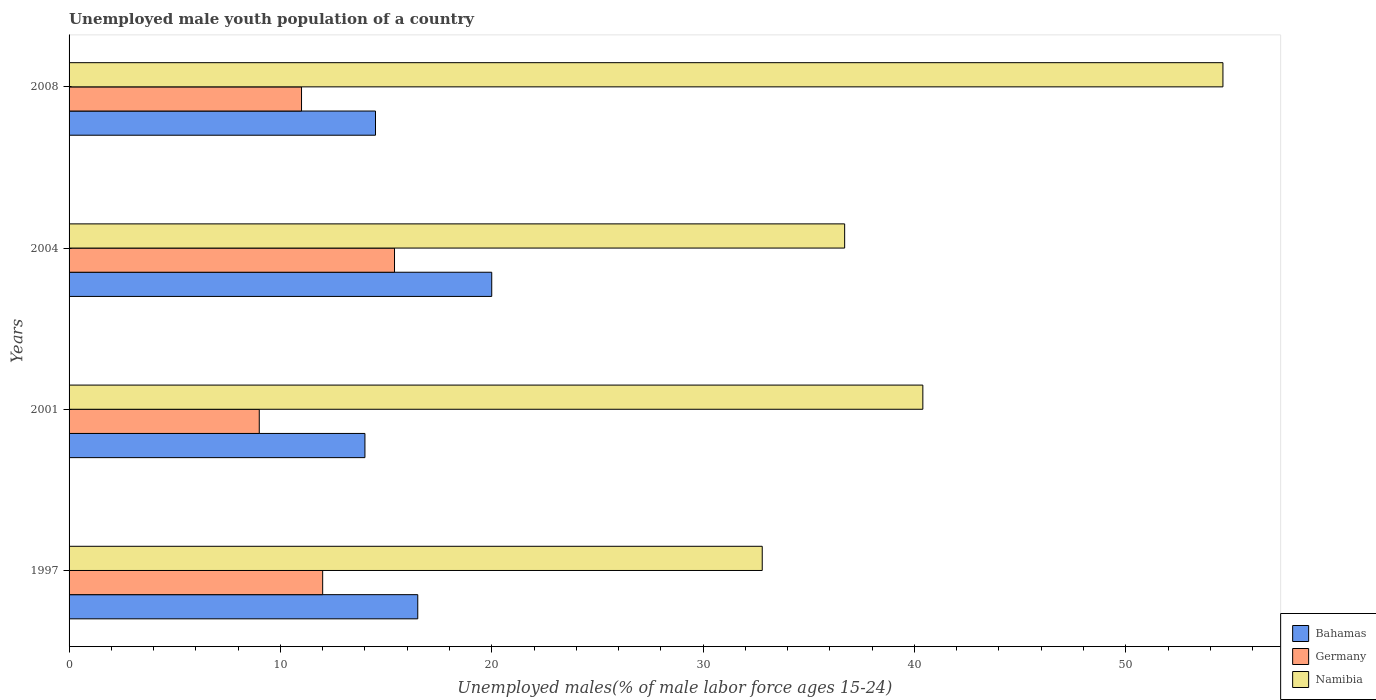How many groups of bars are there?
Provide a succinct answer. 4. Are the number of bars per tick equal to the number of legend labels?
Keep it short and to the point. Yes. What is the label of the 2nd group of bars from the top?
Offer a terse response. 2004. Across all years, what is the maximum percentage of unemployed male youth population in Namibia?
Ensure brevity in your answer.  54.6. What is the total percentage of unemployed male youth population in Namibia in the graph?
Keep it short and to the point. 164.5. What is the difference between the percentage of unemployed male youth population in Germany in 2004 and that in 2008?
Provide a short and direct response. 4.4. What is the difference between the percentage of unemployed male youth population in Germany in 1997 and the percentage of unemployed male youth population in Bahamas in 2001?
Provide a succinct answer. -2. What is the average percentage of unemployed male youth population in Bahamas per year?
Your answer should be compact. 16.25. In the year 2008, what is the difference between the percentage of unemployed male youth population in Namibia and percentage of unemployed male youth population in Germany?
Ensure brevity in your answer.  43.6. What is the ratio of the percentage of unemployed male youth population in Bahamas in 1997 to that in 2001?
Ensure brevity in your answer.  1.18. Is the difference between the percentage of unemployed male youth population in Namibia in 2001 and 2004 greater than the difference between the percentage of unemployed male youth population in Germany in 2001 and 2004?
Provide a succinct answer. Yes. What is the difference between the highest and the second highest percentage of unemployed male youth population in Bahamas?
Make the answer very short. 3.5. What is the difference between the highest and the lowest percentage of unemployed male youth population in Namibia?
Your answer should be compact. 21.8. What does the 1st bar from the top in 1997 represents?
Ensure brevity in your answer.  Namibia. What does the 1st bar from the bottom in 2004 represents?
Make the answer very short. Bahamas. How many bars are there?
Your answer should be compact. 12. How many years are there in the graph?
Make the answer very short. 4. What is the difference between two consecutive major ticks on the X-axis?
Provide a short and direct response. 10. Where does the legend appear in the graph?
Offer a very short reply. Bottom right. How are the legend labels stacked?
Make the answer very short. Vertical. What is the title of the graph?
Make the answer very short. Unemployed male youth population of a country. Does "Germany" appear as one of the legend labels in the graph?
Provide a short and direct response. Yes. What is the label or title of the X-axis?
Keep it short and to the point. Unemployed males(% of male labor force ages 15-24). What is the label or title of the Y-axis?
Keep it short and to the point. Years. What is the Unemployed males(% of male labor force ages 15-24) in Namibia in 1997?
Ensure brevity in your answer.  32.8. What is the Unemployed males(% of male labor force ages 15-24) of Bahamas in 2001?
Ensure brevity in your answer.  14. What is the Unemployed males(% of male labor force ages 15-24) in Namibia in 2001?
Provide a succinct answer. 40.4. What is the Unemployed males(% of male labor force ages 15-24) in Bahamas in 2004?
Ensure brevity in your answer.  20. What is the Unemployed males(% of male labor force ages 15-24) of Germany in 2004?
Keep it short and to the point. 15.4. What is the Unemployed males(% of male labor force ages 15-24) in Namibia in 2004?
Ensure brevity in your answer.  36.7. What is the Unemployed males(% of male labor force ages 15-24) in Bahamas in 2008?
Keep it short and to the point. 14.5. What is the Unemployed males(% of male labor force ages 15-24) of Germany in 2008?
Provide a short and direct response. 11. What is the Unemployed males(% of male labor force ages 15-24) of Namibia in 2008?
Your answer should be very brief. 54.6. Across all years, what is the maximum Unemployed males(% of male labor force ages 15-24) of Germany?
Your answer should be very brief. 15.4. Across all years, what is the maximum Unemployed males(% of male labor force ages 15-24) in Namibia?
Your response must be concise. 54.6. Across all years, what is the minimum Unemployed males(% of male labor force ages 15-24) in Germany?
Your answer should be very brief. 9. Across all years, what is the minimum Unemployed males(% of male labor force ages 15-24) of Namibia?
Your response must be concise. 32.8. What is the total Unemployed males(% of male labor force ages 15-24) in Germany in the graph?
Your response must be concise. 47.4. What is the total Unemployed males(% of male labor force ages 15-24) in Namibia in the graph?
Provide a short and direct response. 164.5. What is the difference between the Unemployed males(% of male labor force ages 15-24) in Bahamas in 1997 and that in 2004?
Offer a very short reply. -3.5. What is the difference between the Unemployed males(% of male labor force ages 15-24) of Namibia in 1997 and that in 2004?
Provide a short and direct response. -3.9. What is the difference between the Unemployed males(% of male labor force ages 15-24) in Bahamas in 1997 and that in 2008?
Offer a very short reply. 2. What is the difference between the Unemployed males(% of male labor force ages 15-24) of Namibia in 1997 and that in 2008?
Offer a very short reply. -21.8. What is the difference between the Unemployed males(% of male labor force ages 15-24) of Bahamas in 2001 and that in 2004?
Your answer should be very brief. -6. What is the difference between the Unemployed males(% of male labor force ages 15-24) in Bahamas in 2001 and that in 2008?
Ensure brevity in your answer.  -0.5. What is the difference between the Unemployed males(% of male labor force ages 15-24) of Bahamas in 2004 and that in 2008?
Give a very brief answer. 5.5. What is the difference between the Unemployed males(% of male labor force ages 15-24) in Germany in 2004 and that in 2008?
Provide a short and direct response. 4.4. What is the difference between the Unemployed males(% of male labor force ages 15-24) in Namibia in 2004 and that in 2008?
Provide a short and direct response. -17.9. What is the difference between the Unemployed males(% of male labor force ages 15-24) in Bahamas in 1997 and the Unemployed males(% of male labor force ages 15-24) in Namibia in 2001?
Provide a short and direct response. -23.9. What is the difference between the Unemployed males(% of male labor force ages 15-24) in Germany in 1997 and the Unemployed males(% of male labor force ages 15-24) in Namibia in 2001?
Offer a very short reply. -28.4. What is the difference between the Unemployed males(% of male labor force ages 15-24) in Bahamas in 1997 and the Unemployed males(% of male labor force ages 15-24) in Germany in 2004?
Provide a succinct answer. 1.1. What is the difference between the Unemployed males(% of male labor force ages 15-24) in Bahamas in 1997 and the Unemployed males(% of male labor force ages 15-24) in Namibia in 2004?
Your response must be concise. -20.2. What is the difference between the Unemployed males(% of male labor force ages 15-24) of Germany in 1997 and the Unemployed males(% of male labor force ages 15-24) of Namibia in 2004?
Ensure brevity in your answer.  -24.7. What is the difference between the Unemployed males(% of male labor force ages 15-24) in Bahamas in 1997 and the Unemployed males(% of male labor force ages 15-24) in Germany in 2008?
Offer a terse response. 5.5. What is the difference between the Unemployed males(% of male labor force ages 15-24) in Bahamas in 1997 and the Unemployed males(% of male labor force ages 15-24) in Namibia in 2008?
Offer a terse response. -38.1. What is the difference between the Unemployed males(% of male labor force ages 15-24) of Germany in 1997 and the Unemployed males(% of male labor force ages 15-24) of Namibia in 2008?
Offer a very short reply. -42.6. What is the difference between the Unemployed males(% of male labor force ages 15-24) of Bahamas in 2001 and the Unemployed males(% of male labor force ages 15-24) of Germany in 2004?
Offer a terse response. -1.4. What is the difference between the Unemployed males(% of male labor force ages 15-24) of Bahamas in 2001 and the Unemployed males(% of male labor force ages 15-24) of Namibia in 2004?
Provide a succinct answer. -22.7. What is the difference between the Unemployed males(% of male labor force ages 15-24) of Germany in 2001 and the Unemployed males(% of male labor force ages 15-24) of Namibia in 2004?
Keep it short and to the point. -27.7. What is the difference between the Unemployed males(% of male labor force ages 15-24) of Bahamas in 2001 and the Unemployed males(% of male labor force ages 15-24) of Germany in 2008?
Make the answer very short. 3. What is the difference between the Unemployed males(% of male labor force ages 15-24) of Bahamas in 2001 and the Unemployed males(% of male labor force ages 15-24) of Namibia in 2008?
Provide a succinct answer. -40.6. What is the difference between the Unemployed males(% of male labor force ages 15-24) of Germany in 2001 and the Unemployed males(% of male labor force ages 15-24) of Namibia in 2008?
Your answer should be compact. -45.6. What is the difference between the Unemployed males(% of male labor force ages 15-24) of Bahamas in 2004 and the Unemployed males(% of male labor force ages 15-24) of Germany in 2008?
Provide a succinct answer. 9. What is the difference between the Unemployed males(% of male labor force ages 15-24) in Bahamas in 2004 and the Unemployed males(% of male labor force ages 15-24) in Namibia in 2008?
Offer a very short reply. -34.6. What is the difference between the Unemployed males(% of male labor force ages 15-24) in Germany in 2004 and the Unemployed males(% of male labor force ages 15-24) in Namibia in 2008?
Your answer should be very brief. -39.2. What is the average Unemployed males(% of male labor force ages 15-24) of Bahamas per year?
Your answer should be compact. 16.25. What is the average Unemployed males(% of male labor force ages 15-24) in Germany per year?
Offer a terse response. 11.85. What is the average Unemployed males(% of male labor force ages 15-24) of Namibia per year?
Your answer should be very brief. 41.12. In the year 1997, what is the difference between the Unemployed males(% of male labor force ages 15-24) in Bahamas and Unemployed males(% of male labor force ages 15-24) in Germany?
Your answer should be very brief. 4.5. In the year 1997, what is the difference between the Unemployed males(% of male labor force ages 15-24) of Bahamas and Unemployed males(% of male labor force ages 15-24) of Namibia?
Your answer should be compact. -16.3. In the year 1997, what is the difference between the Unemployed males(% of male labor force ages 15-24) in Germany and Unemployed males(% of male labor force ages 15-24) in Namibia?
Provide a short and direct response. -20.8. In the year 2001, what is the difference between the Unemployed males(% of male labor force ages 15-24) of Bahamas and Unemployed males(% of male labor force ages 15-24) of Germany?
Provide a succinct answer. 5. In the year 2001, what is the difference between the Unemployed males(% of male labor force ages 15-24) of Bahamas and Unemployed males(% of male labor force ages 15-24) of Namibia?
Give a very brief answer. -26.4. In the year 2001, what is the difference between the Unemployed males(% of male labor force ages 15-24) of Germany and Unemployed males(% of male labor force ages 15-24) of Namibia?
Your answer should be very brief. -31.4. In the year 2004, what is the difference between the Unemployed males(% of male labor force ages 15-24) of Bahamas and Unemployed males(% of male labor force ages 15-24) of Namibia?
Your answer should be compact. -16.7. In the year 2004, what is the difference between the Unemployed males(% of male labor force ages 15-24) of Germany and Unemployed males(% of male labor force ages 15-24) of Namibia?
Give a very brief answer. -21.3. In the year 2008, what is the difference between the Unemployed males(% of male labor force ages 15-24) of Bahamas and Unemployed males(% of male labor force ages 15-24) of Namibia?
Your response must be concise. -40.1. In the year 2008, what is the difference between the Unemployed males(% of male labor force ages 15-24) in Germany and Unemployed males(% of male labor force ages 15-24) in Namibia?
Offer a very short reply. -43.6. What is the ratio of the Unemployed males(% of male labor force ages 15-24) in Bahamas in 1997 to that in 2001?
Ensure brevity in your answer.  1.18. What is the ratio of the Unemployed males(% of male labor force ages 15-24) of Germany in 1997 to that in 2001?
Your answer should be very brief. 1.33. What is the ratio of the Unemployed males(% of male labor force ages 15-24) in Namibia in 1997 to that in 2001?
Offer a terse response. 0.81. What is the ratio of the Unemployed males(% of male labor force ages 15-24) in Bahamas in 1997 to that in 2004?
Keep it short and to the point. 0.82. What is the ratio of the Unemployed males(% of male labor force ages 15-24) in Germany in 1997 to that in 2004?
Your response must be concise. 0.78. What is the ratio of the Unemployed males(% of male labor force ages 15-24) of Namibia in 1997 to that in 2004?
Your answer should be very brief. 0.89. What is the ratio of the Unemployed males(% of male labor force ages 15-24) in Bahamas in 1997 to that in 2008?
Your response must be concise. 1.14. What is the ratio of the Unemployed males(% of male labor force ages 15-24) in Germany in 1997 to that in 2008?
Keep it short and to the point. 1.09. What is the ratio of the Unemployed males(% of male labor force ages 15-24) of Namibia in 1997 to that in 2008?
Your answer should be compact. 0.6. What is the ratio of the Unemployed males(% of male labor force ages 15-24) in Germany in 2001 to that in 2004?
Your answer should be compact. 0.58. What is the ratio of the Unemployed males(% of male labor force ages 15-24) in Namibia in 2001 to that in 2004?
Offer a very short reply. 1.1. What is the ratio of the Unemployed males(% of male labor force ages 15-24) of Bahamas in 2001 to that in 2008?
Your answer should be very brief. 0.97. What is the ratio of the Unemployed males(% of male labor force ages 15-24) of Germany in 2001 to that in 2008?
Make the answer very short. 0.82. What is the ratio of the Unemployed males(% of male labor force ages 15-24) of Namibia in 2001 to that in 2008?
Give a very brief answer. 0.74. What is the ratio of the Unemployed males(% of male labor force ages 15-24) in Bahamas in 2004 to that in 2008?
Keep it short and to the point. 1.38. What is the ratio of the Unemployed males(% of male labor force ages 15-24) in Germany in 2004 to that in 2008?
Provide a short and direct response. 1.4. What is the ratio of the Unemployed males(% of male labor force ages 15-24) in Namibia in 2004 to that in 2008?
Offer a terse response. 0.67. What is the difference between the highest and the second highest Unemployed males(% of male labor force ages 15-24) in Germany?
Give a very brief answer. 3.4. What is the difference between the highest and the second highest Unemployed males(% of male labor force ages 15-24) in Namibia?
Your answer should be very brief. 14.2. What is the difference between the highest and the lowest Unemployed males(% of male labor force ages 15-24) of Bahamas?
Keep it short and to the point. 6. What is the difference between the highest and the lowest Unemployed males(% of male labor force ages 15-24) in Namibia?
Provide a short and direct response. 21.8. 